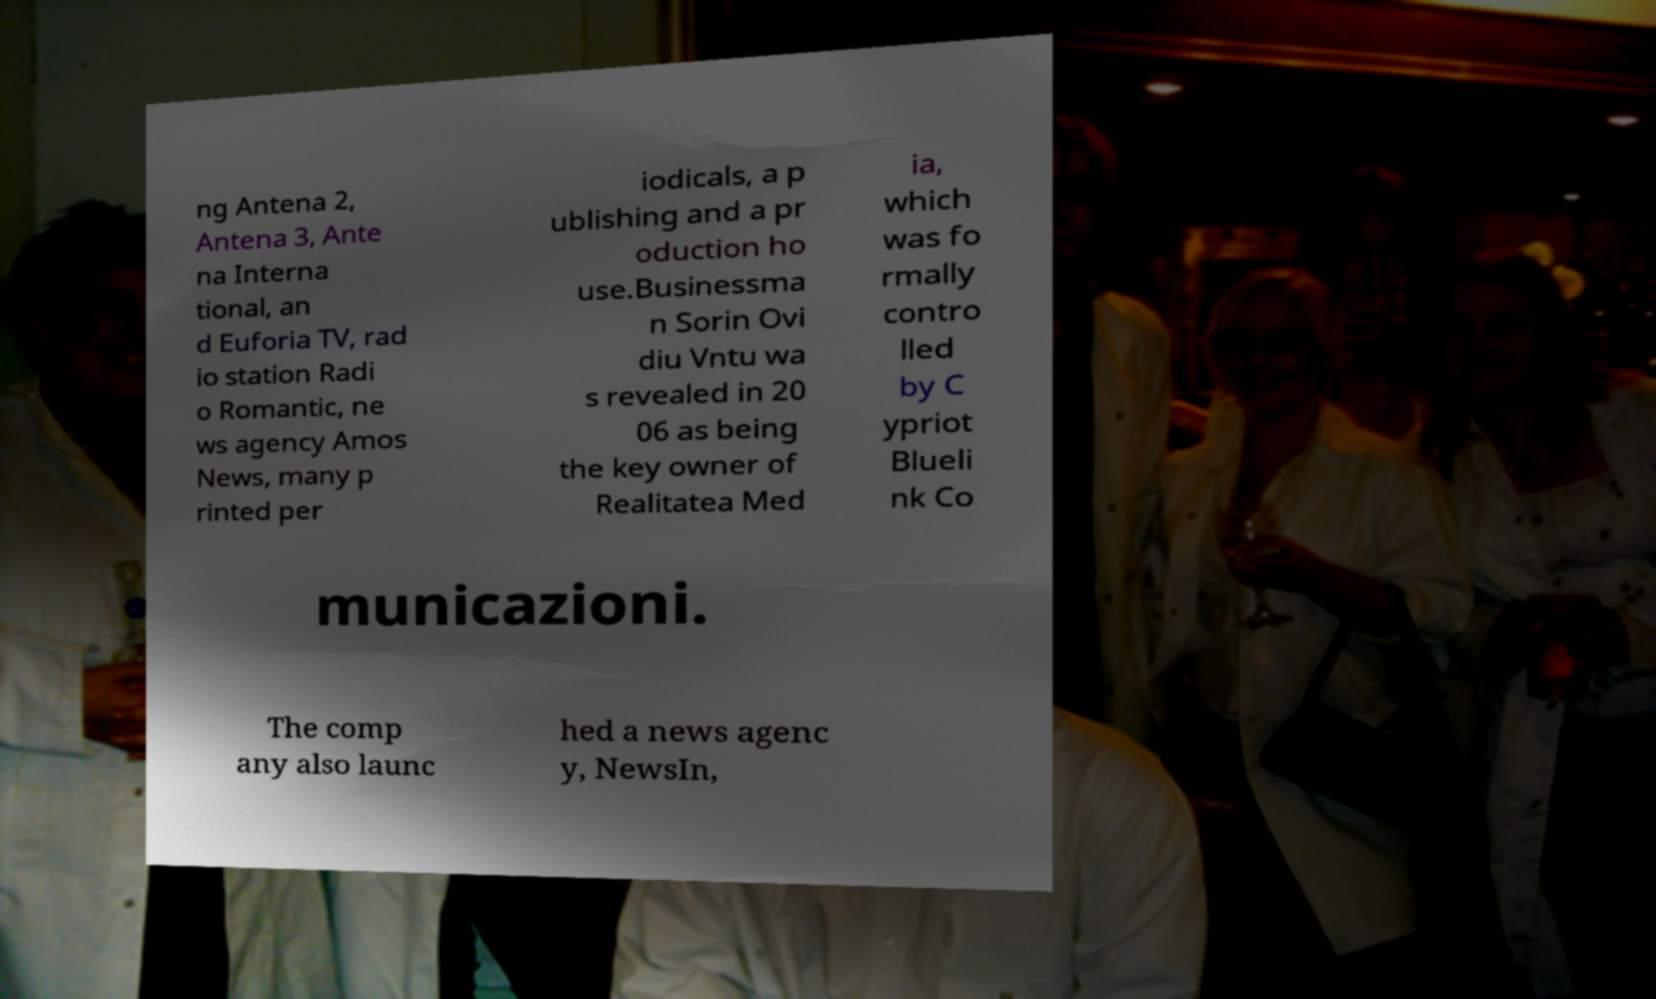I need the written content from this picture converted into text. Can you do that? ng Antena 2, Antena 3, Ante na Interna tional, an d Euforia TV, rad io station Radi o Romantic, ne ws agency Amos News, many p rinted per iodicals, a p ublishing and a pr oduction ho use.Businessma n Sorin Ovi diu Vntu wa s revealed in 20 06 as being the key owner of Realitatea Med ia, which was fo rmally contro lled by C ypriot Blueli nk Co municazioni. The comp any also launc hed a news agenc y, NewsIn, 